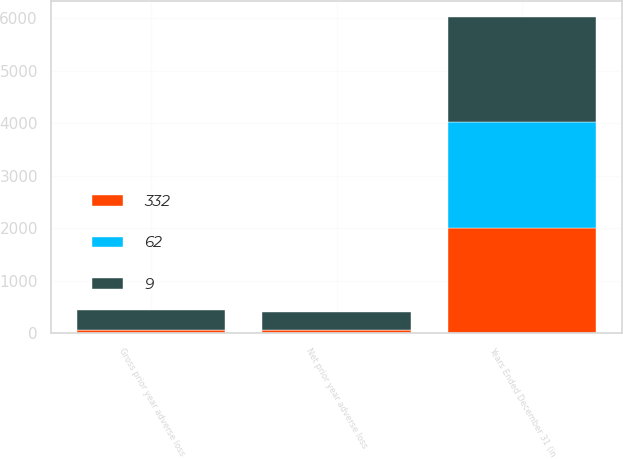Convert chart. <chart><loc_0><loc_0><loc_500><loc_500><stacked_bar_chart><ecel><fcel>Years Ended December 31 (in<fcel>Gross prior year adverse loss<fcel>Net prior year adverse loss<nl><fcel>9<fcel>2010<fcel>379<fcel>332<nl><fcel>62<fcel>2009<fcel>9<fcel>9<nl><fcel>332<fcel>2008<fcel>62<fcel>62<nl></chart> 